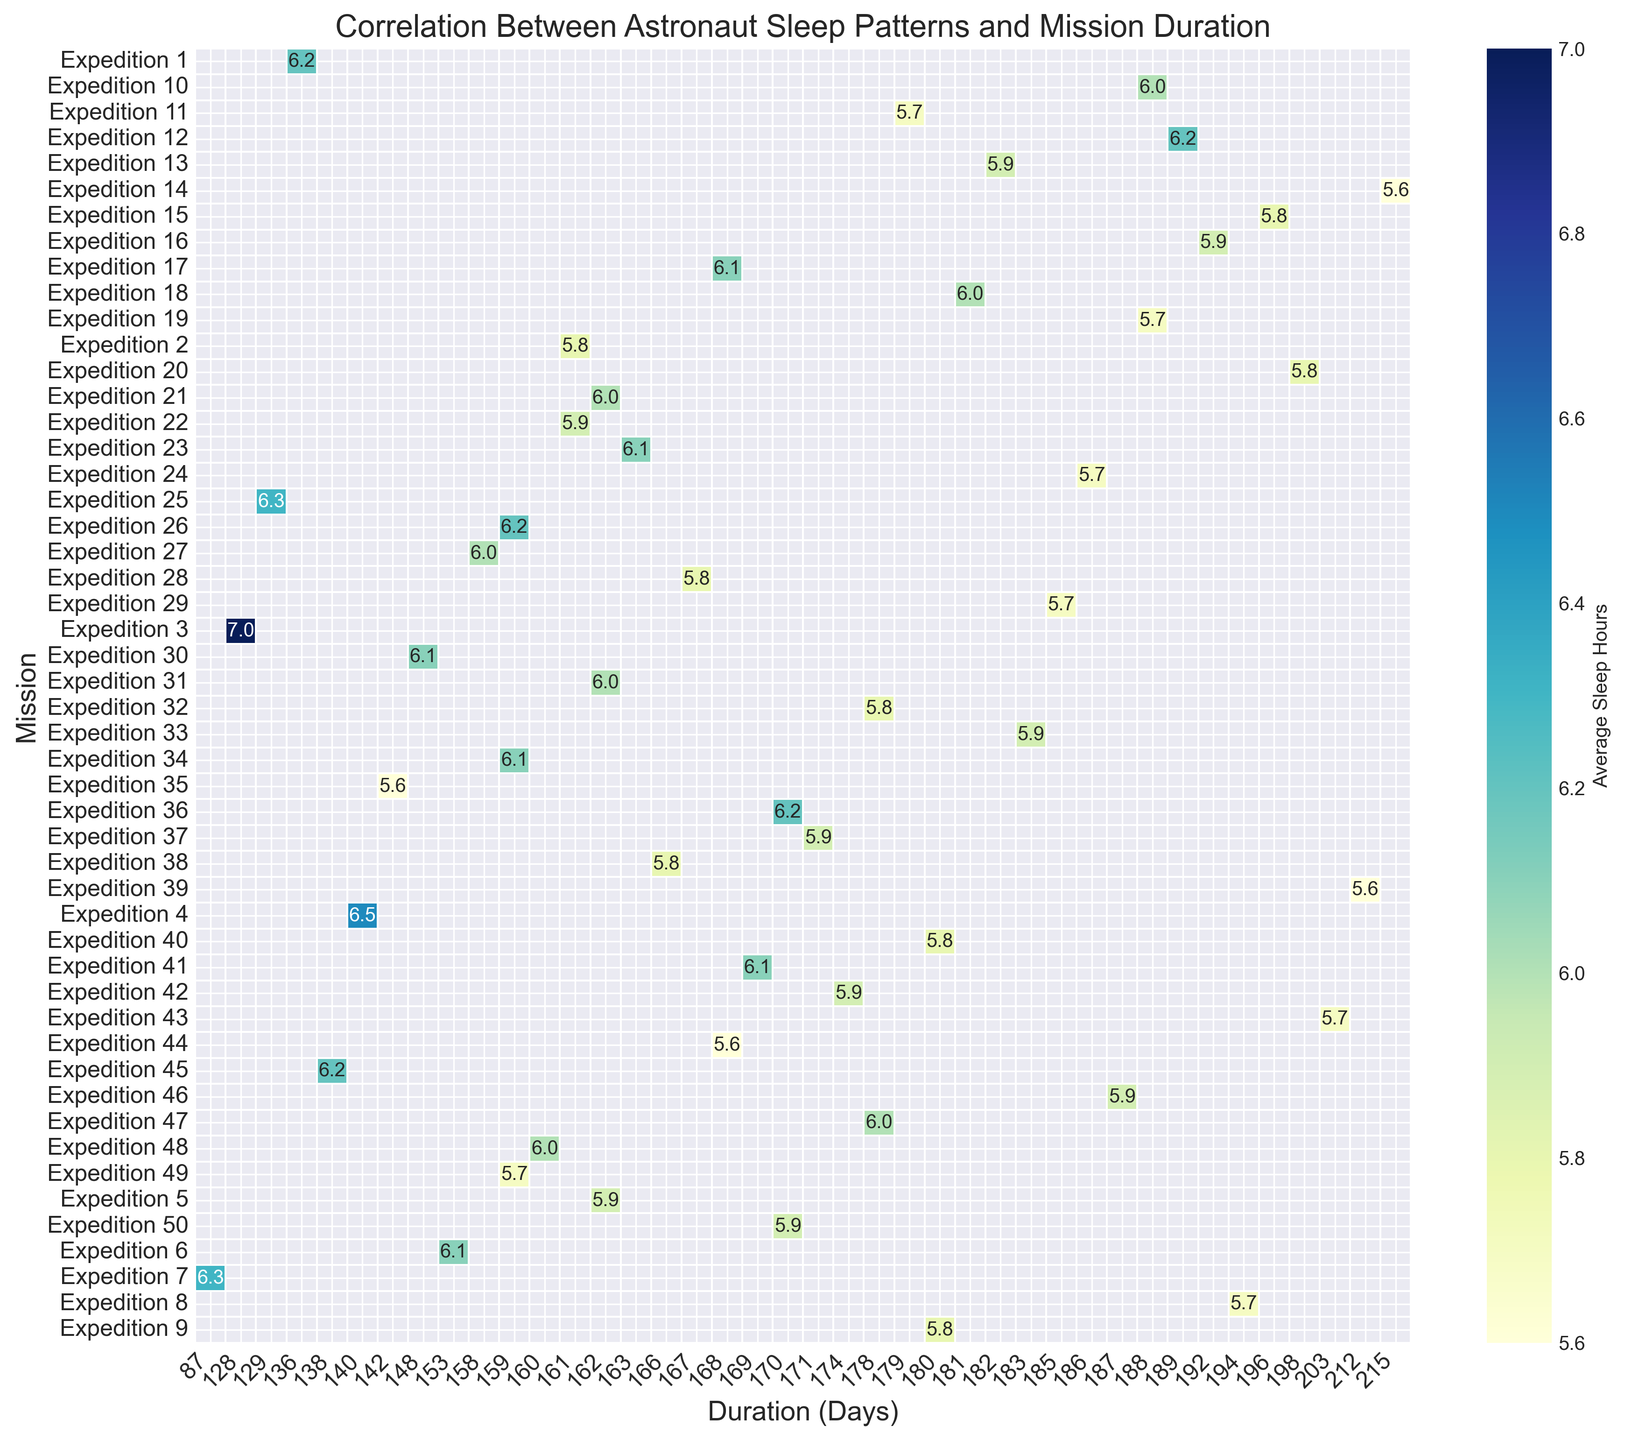What is the average sleep hours for Expedition 14? Locate Expedition 14 in the y-axis, then look at the corresponding value in the grid. The value is 5.6, which represents the average sleep hours for Expedition 14.
Answer: 5.6 Which mission had the shortest duration, and what were the average sleep hours for that mission? From the heatmap, identify the shortest bar on the x-axis (Duration in days). The mission with the shortest duration is Expedition 7 with 87 days. The average sleep hours for this mission, as directly observed from the heatmap, were 6.3 hours.
Answer: Expedition 7, 6.3 Identify the mission with the highest recorded average sleep hours. Look through the heatmap for the highest value in the grid. The highest sleep hours recorded is 7.0, corresponding to Expedition 3.
Answer: Expedition 3 Compare the average sleep hours of missions that lasted 200 days or more. What trend do you observe in sleep hours as mission duration increases? Identify the missions with durations 200 days or more by inspecting the higher end of the x-axis. These missions are Expedition 14, Expedition 39, and Expedition 43, with sleep values of 5.6, 5.6, and 5.7, respectively. As mission duration increases to 200 days or more, average sleep hours tend to be lower, ranging between 5.6 and 5.7 hours.
Answer: Sleep hours decrease Which missions had an average sleep of exactly 6.0 hours, and what were their respective durations? Find the cells in the heatmap with a value of exactly 6.0. These correspond to Expeditions 10, 18, 31, 41, and 47. The durations for these missions are 188, 181, 162, 169, and 178 days, respectively.
Answer: Expeditions 10, 18, 31, 41, 47; Durations: 188, 181, 162, 169, 178 days Is there a significant trend or correlation between the mission duration and average sleep hours? Examine the overall color gradient and distribution of the heatmap. A lighter color represents higher sleep hours, while a darker color represents fewer sleep hours. There is no clear linear trend, but generally, shorter durations show slightly higher sleep hours compared to longer durations, which have more darker shades (indicating lower sleep hours).
Answer: No significant correlation Calculate the average sleep hours across all missions with durations between 160 and 170 days. Identify the missions in the range of 160 and 170 days. These are Expeditions 21, 22, 23, 26, 27, 28, 17, 30, and 41, with respective sleep values of 6.0, 5.9, 6.1, 6.2, 6.0, 5.9, 6.1, 6.1, and 6.1. The average is calculated as (6.0 + 5.9 + 6.1 + 6.2 + 6.0 + 5.9 + 6.1 + 6.1 + 6.1) / 9 ≈ 6.05.
Answer: 6.05 Does any mission have exactly the same value for average sleep hours as its duration in days if rounded to the nearest integer? Round all sleep hours and corresponding durations to the nearest integer, then compare. No missions have the same sleep hours and duration when rounded to the nearest integer.
Answer: No 